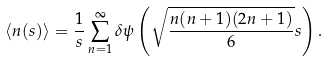Convert formula to latex. <formula><loc_0><loc_0><loc_500><loc_500>\langle n ( s ) \rangle = \frac { 1 } { s } \sum _ { n = 1 } ^ { \infty } \delta \psi \left ( \sqrt { \frac { n ( n + 1 ) ( 2 n + 1 ) } { 6 } } s \right ) .</formula> 